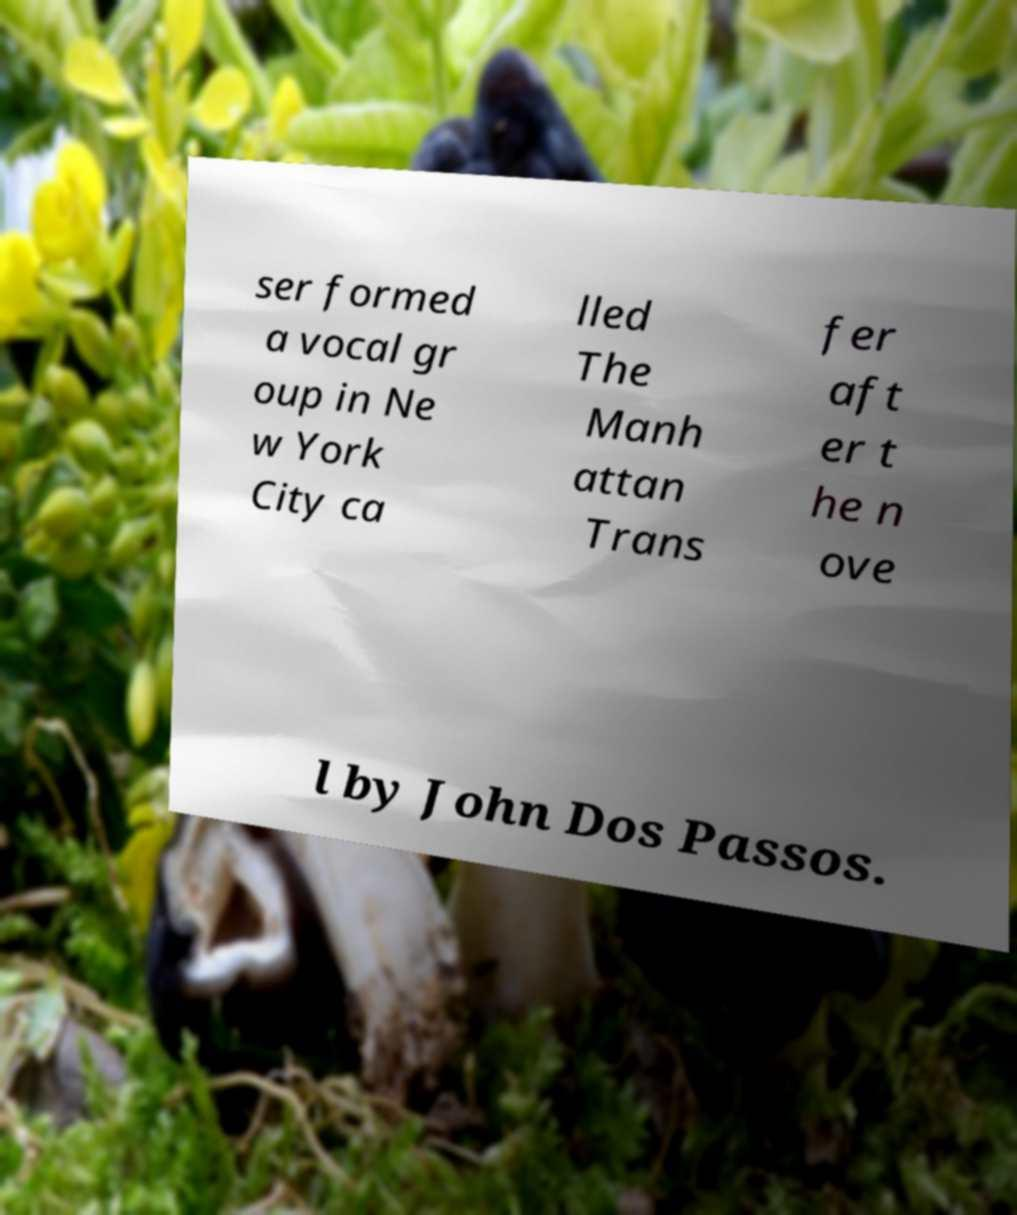What messages or text are displayed in this image? I need them in a readable, typed format. ser formed a vocal gr oup in Ne w York City ca lled The Manh attan Trans fer aft er t he n ove l by John Dos Passos. 